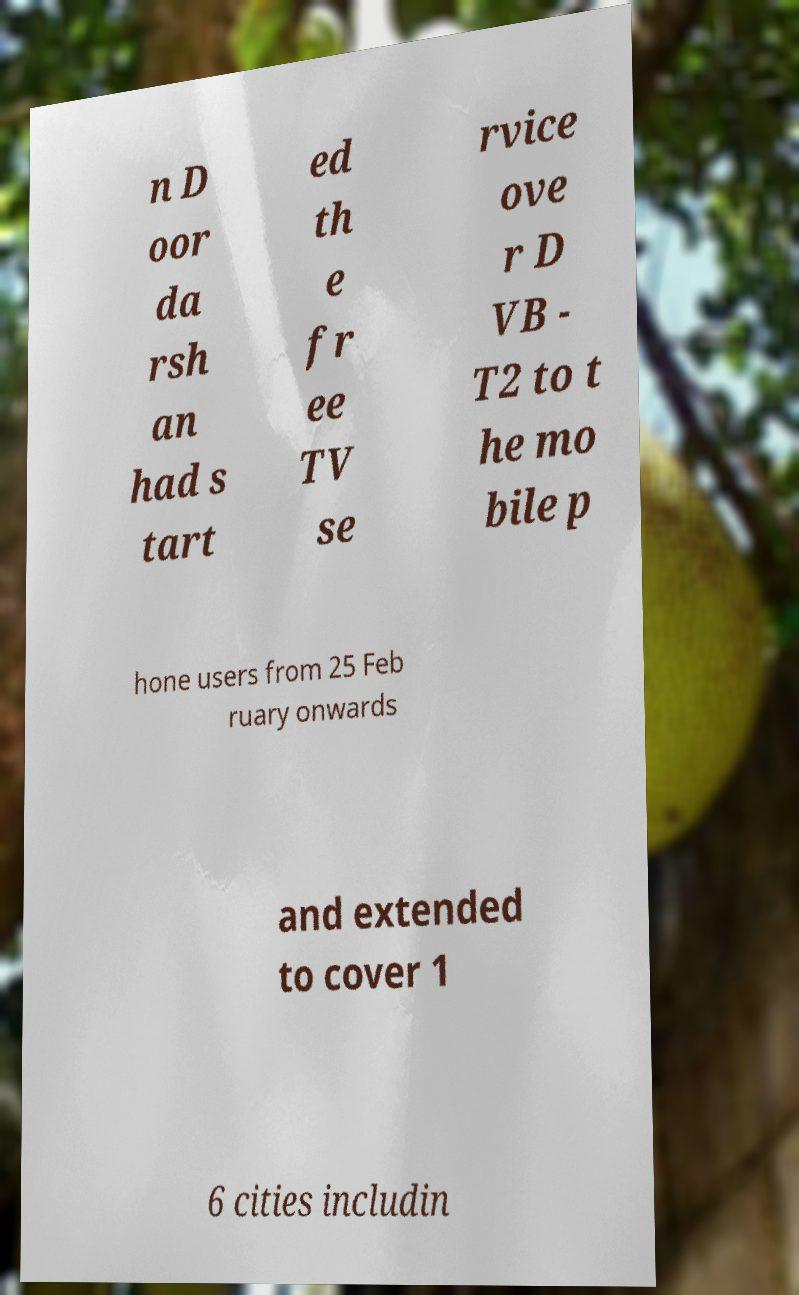Can you accurately transcribe the text from the provided image for me? n D oor da rsh an had s tart ed th e fr ee TV se rvice ove r D VB - T2 to t he mo bile p hone users from 25 Feb ruary onwards and extended to cover 1 6 cities includin 